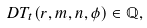Convert formula to latex. <formula><loc_0><loc_0><loc_500><loc_500>\ D T _ { t } ( r , m , n , \phi ) \in \mathbb { Q } ,</formula> 